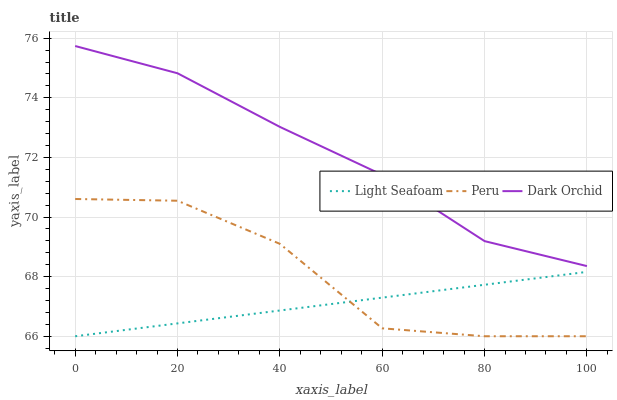Does Peru have the minimum area under the curve?
Answer yes or no. No. Does Peru have the maximum area under the curve?
Answer yes or no. No. Is Dark Orchid the smoothest?
Answer yes or no. No. Is Dark Orchid the roughest?
Answer yes or no. No. Does Dark Orchid have the lowest value?
Answer yes or no. No. Does Peru have the highest value?
Answer yes or no. No. Is Peru less than Dark Orchid?
Answer yes or no. Yes. Is Dark Orchid greater than Light Seafoam?
Answer yes or no. Yes. Does Peru intersect Dark Orchid?
Answer yes or no. No. 